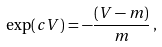<formula> <loc_0><loc_0><loc_500><loc_500>\exp ( c V ) = - \frac { ( V - m ) } { m } \, ,</formula> 